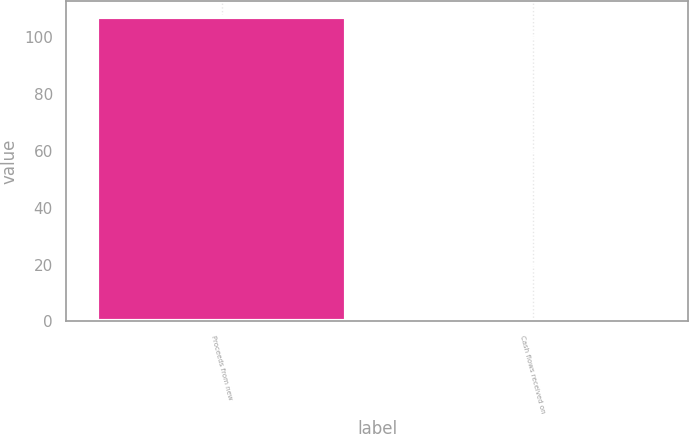Convert chart to OTSL. <chart><loc_0><loc_0><loc_500><loc_500><bar_chart><fcel>Proceeds from new<fcel>Cash flows received on<nl><fcel>107.2<fcel>0.3<nl></chart> 